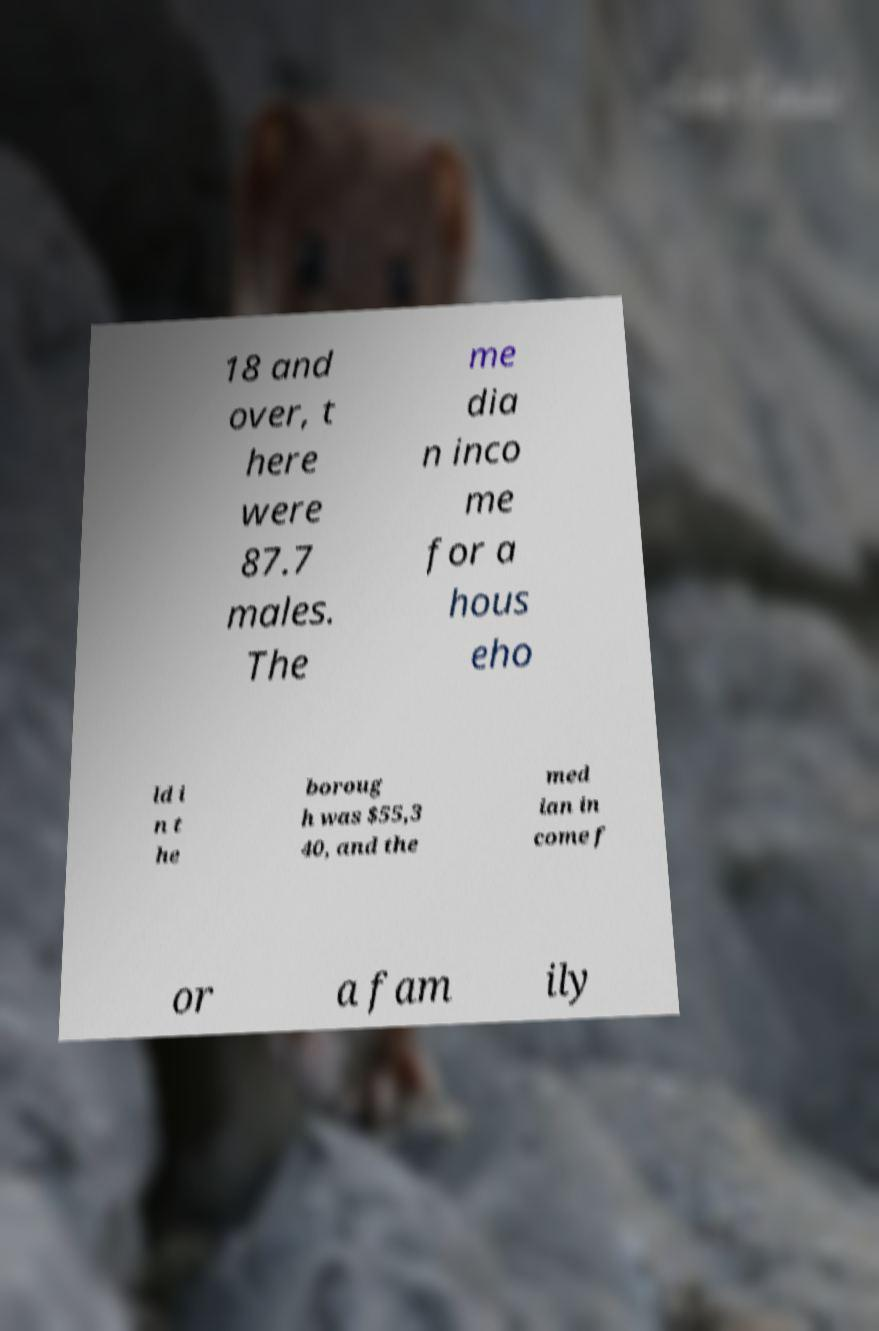Can you read and provide the text displayed in the image?This photo seems to have some interesting text. Can you extract and type it out for me? 18 and over, t here were 87.7 males. The me dia n inco me for a hous eho ld i n t he boroug h was $55,3 40, and the med ian in come f or a fam ily 